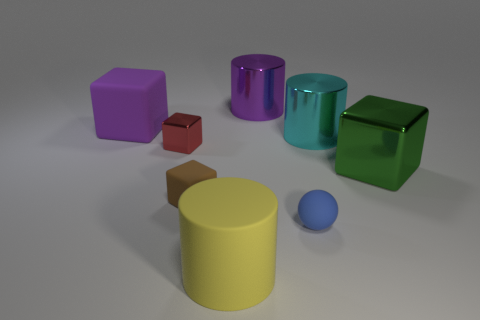Which objects seem to have a reflective surface? In the given image, the purple cube, turquoise cylinder, and green cube display reflective surfaces, indicated by the light and environment reflecting off of them. This adds visual interest and depth to the scene. 